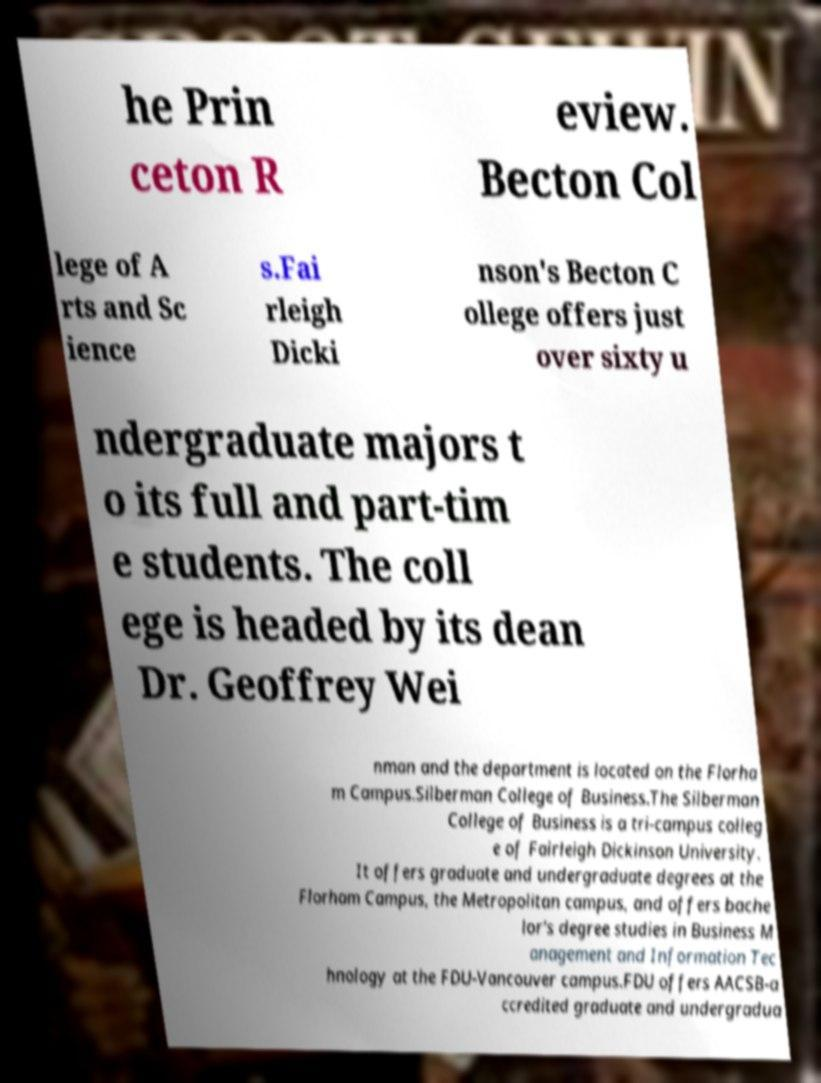Please identify and transcribe the text found in this image. he Prin ceton R eview. Becton Col lege of A rts and Sc ience s.Fai rleigh Dicki nson's Becton C ollege offers just over sixty u ndergraduate majors t o its full and part-tim e students. The coll ege is headed by its dean Dr. Geoffrey Wei nman and the department is located on the Florha m Campus.Silberman College of Business.The Silberman College of Business is a tri-campus colleg e of Fairleigh Dickinson University. It offers graduate and undergraduate degrees at the Florham Campus, the Metropolitan campus, and offers bache lor's degree studies in Business M anagement and Information Tec hnology at the FDU-Vancouver campus.FDU offers AACSB-a ccredited graduate and undergradua 